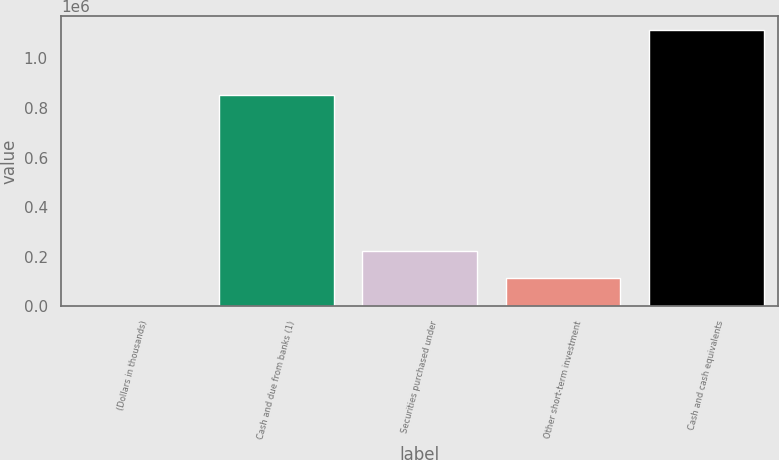Convert chart to OTSL. <chart><loc_0><loc_0><loc_500><loc_500><bar_chart><fcel>(Dollars in thousands)<fcel>Cash and due from banks (1)<fcel>Securities purchased under<fcel>Other short-term investment<fcel>Cash and cash equivalents<nl><fcel>2011<fcel>852010<fcel>224598<fcel>113305<fcel>1.11495e+06<nl></chart> 